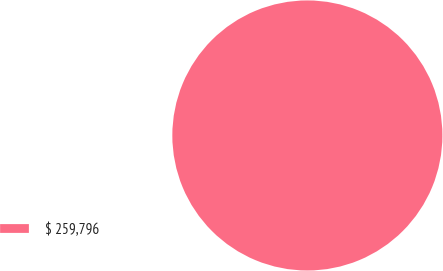<chart> <loc_0><loc_0><loc_500><loc_500><pie_chart><fcel>$ 259,796<nl><fcel>100.0%<nl></chart> 